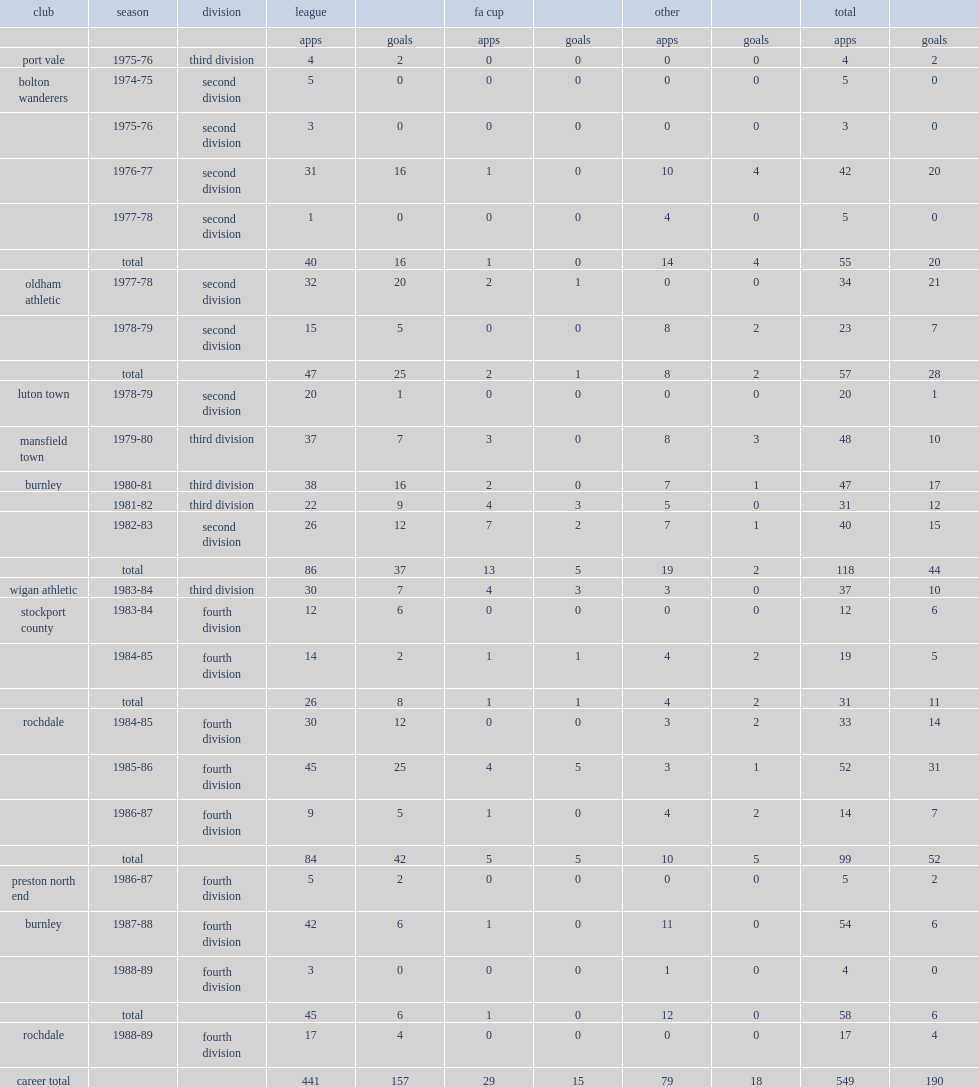How many goals did steve taylor score for wigan athletic in the 1983-84 season? 10.0. 